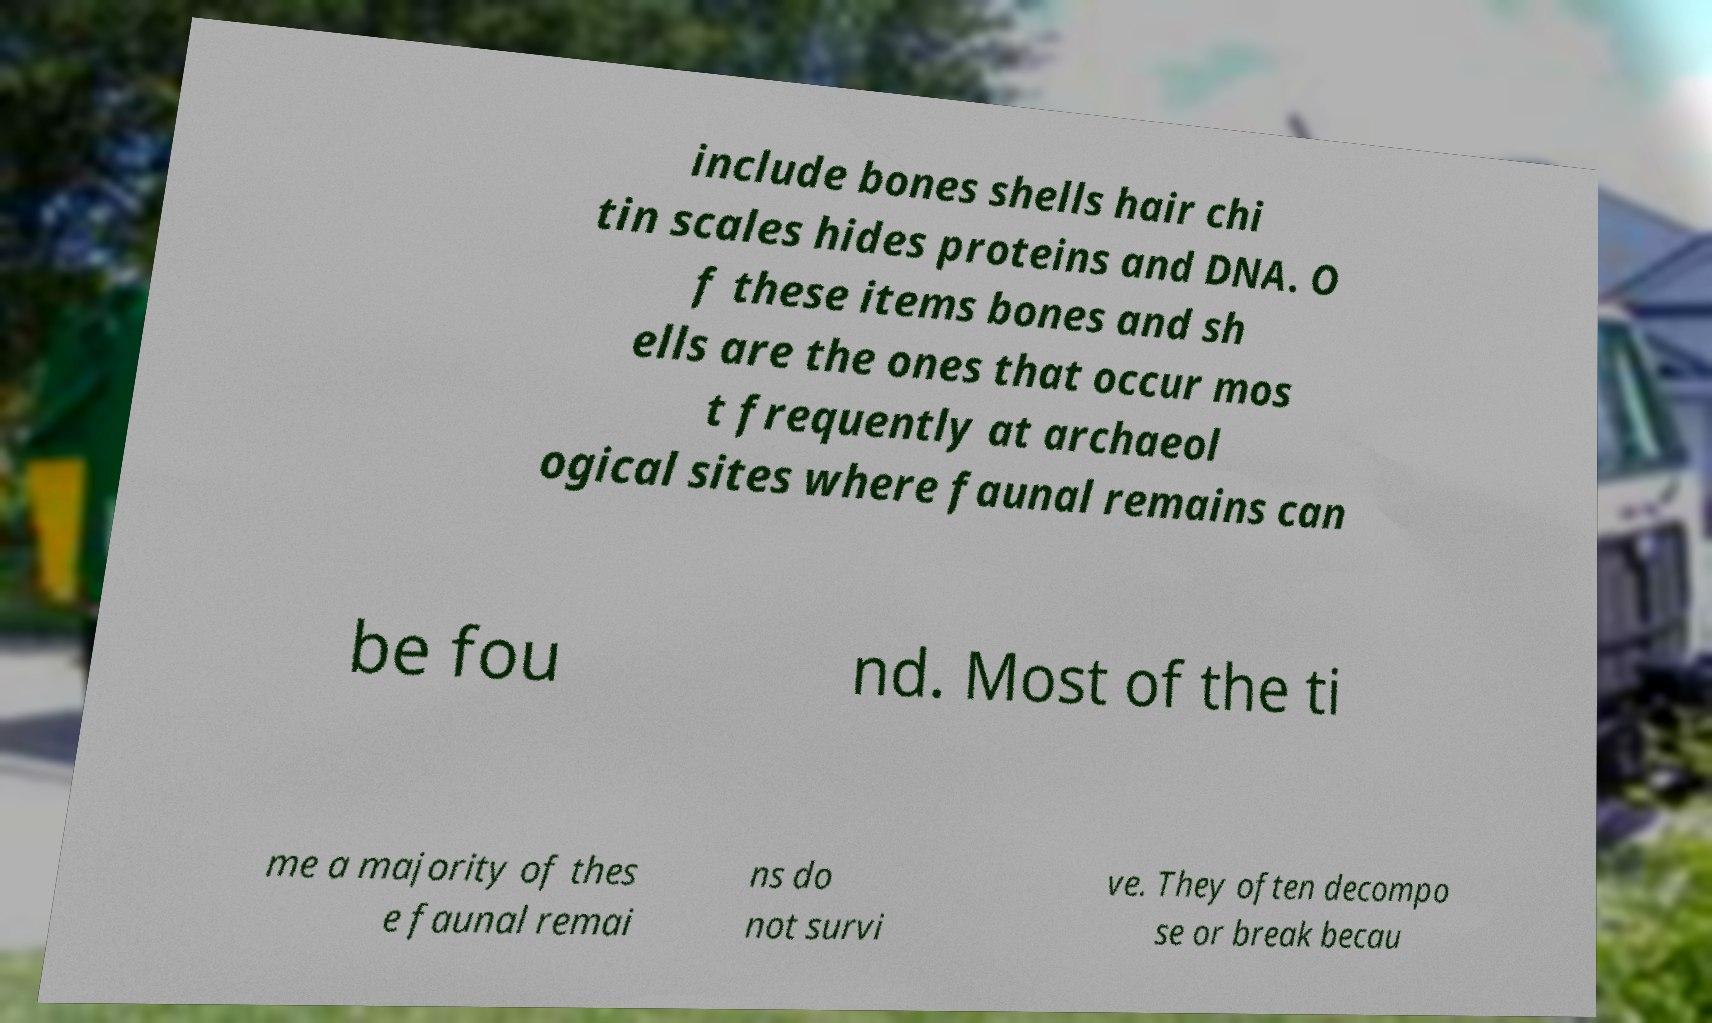Can you read and provide the text displayed in the image?This photo seems to have some interesting text. Can you extract and type it out for me? include bones shells hair chi tin scales hides proteins and DNA. O f these items bones and sh ells are the ones that occur mos t frequently at archaeol ogical sites where faunal remains can be fou nd. Most of the ti me a majority of thes e faunal remai ns do not survi ve. They often decompo se or break becau 